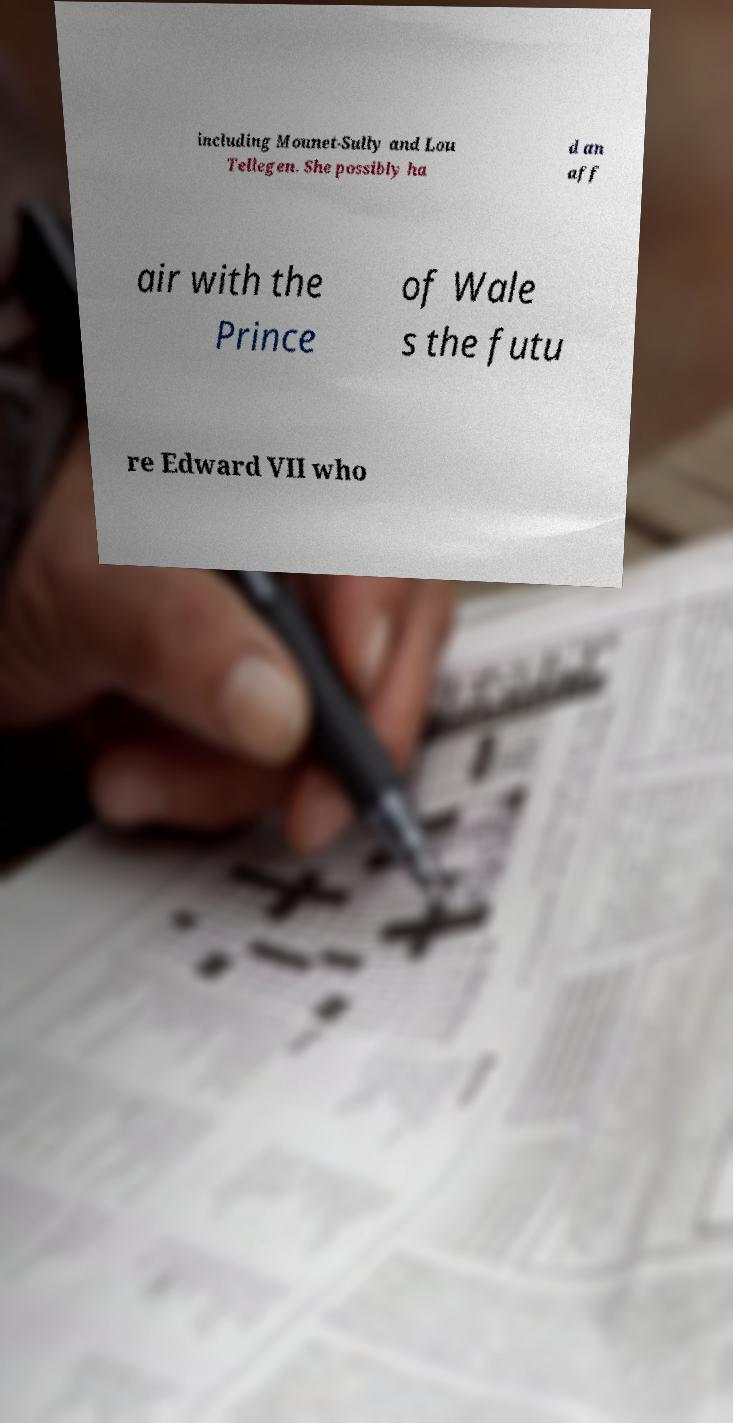For documentation purposes, I need the text within this image transcribed. Could you provide that? including Mounet-Sully and Lou Tellegen. She possibly ha d an aff air with the Prince of Wale s the futu re Edward VII who 